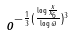Convert formula to latex. <formula><loc_0><loc_0><loc_500><loc_500>o ^ { - \frac { 1 } { 3 } ( \frac { \log \frac { x } { x _ { 6 } } } { \log \varpi } ) ^ { 3 } }</formula> 